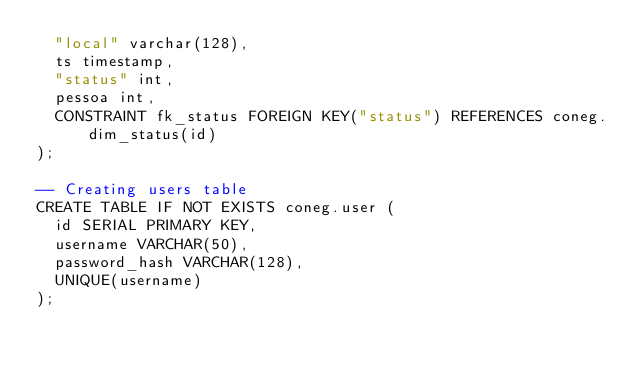Convert code to text. <code><loc_0><loc_0><loc_500><loc_500><_SQL_>  "local" varchar(128),
  ts timestamp,
  "status" int,
  pessoa int,
  CONSTRAINT fk_status FOREIGN KEY("status") REFERENCES coneg.dim_status(id)
);

-- Creating users table
CREATE TABLE IF NOT EXISTS coneg.user (
  id SERIAL PRIMARY KEY,
  username VARCHAR(50),
  password_hash VARCHAR(128),
  UNIQUE(username)
);</code> 